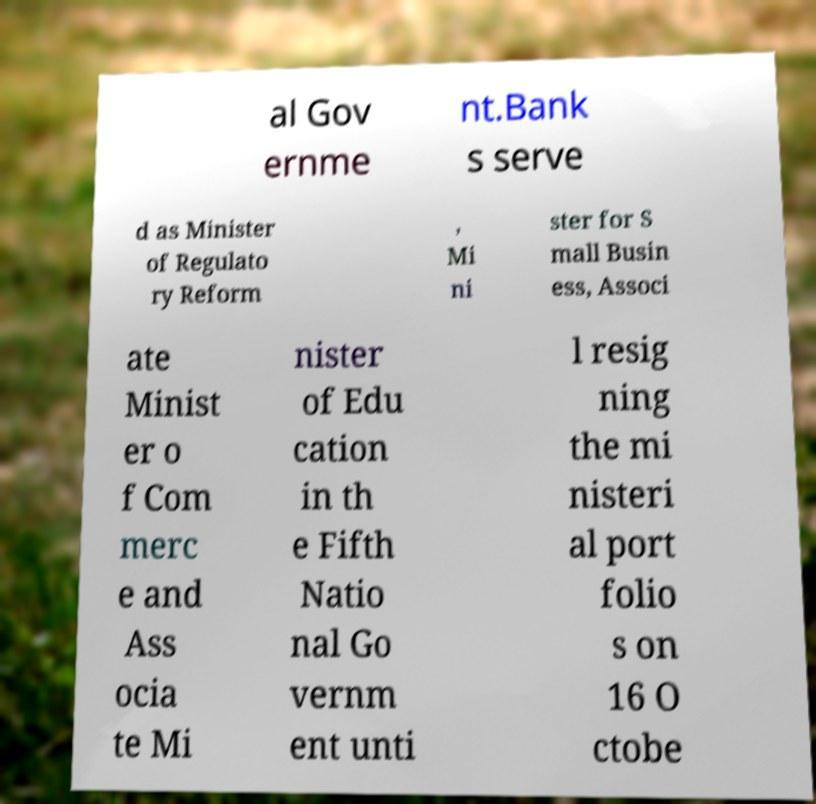Please identify and transcribe the text found in this image. al Gov ernme nt.Bank s serve d as Minister of Regulato ry Reform , Mi ni ster for S mall Busin ess, Associ ate Minist er o f Com merc e and Ass ocia te Mi nister of Edu cation in th e Fifth Natio nal Go vernm ent unti l resig ning the mi nisteri al port folio s on 16 O ctobe 